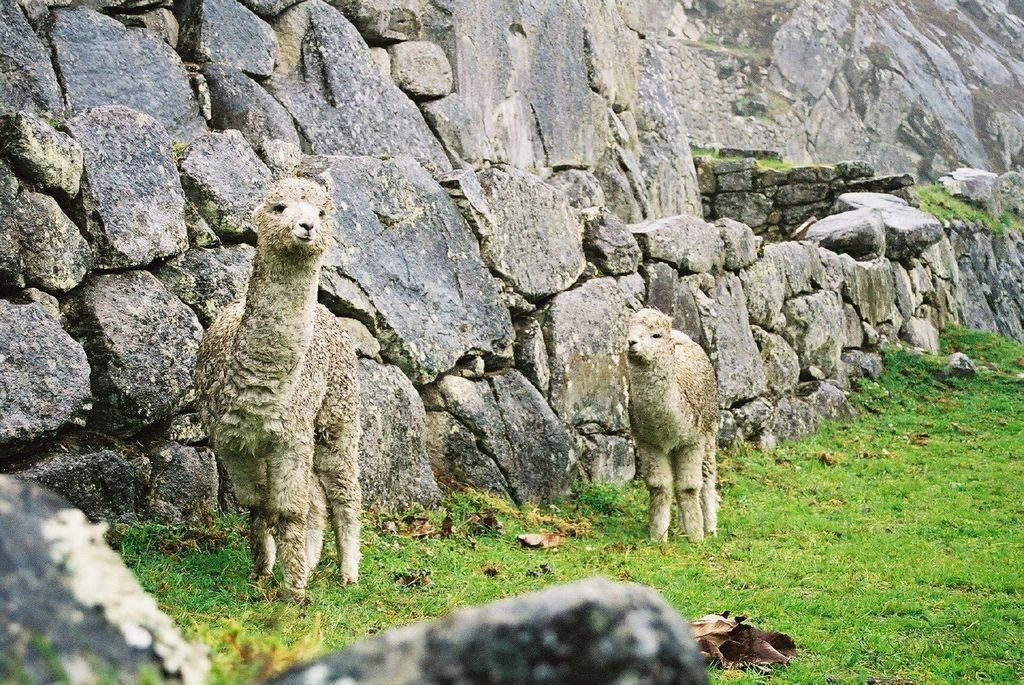What type of living organisms are present in the image? There are animals in the image. What is the position of the animals in relation to the ground? The animals are standing on the ground. What can be seen in the background of the image? There is grass and a wall visible in the background of the image. What type of clock is being protested by the animals in the image? There is no clock or protest present in the image; it features animals standing on the ground with grass and a wall visible in the background. 